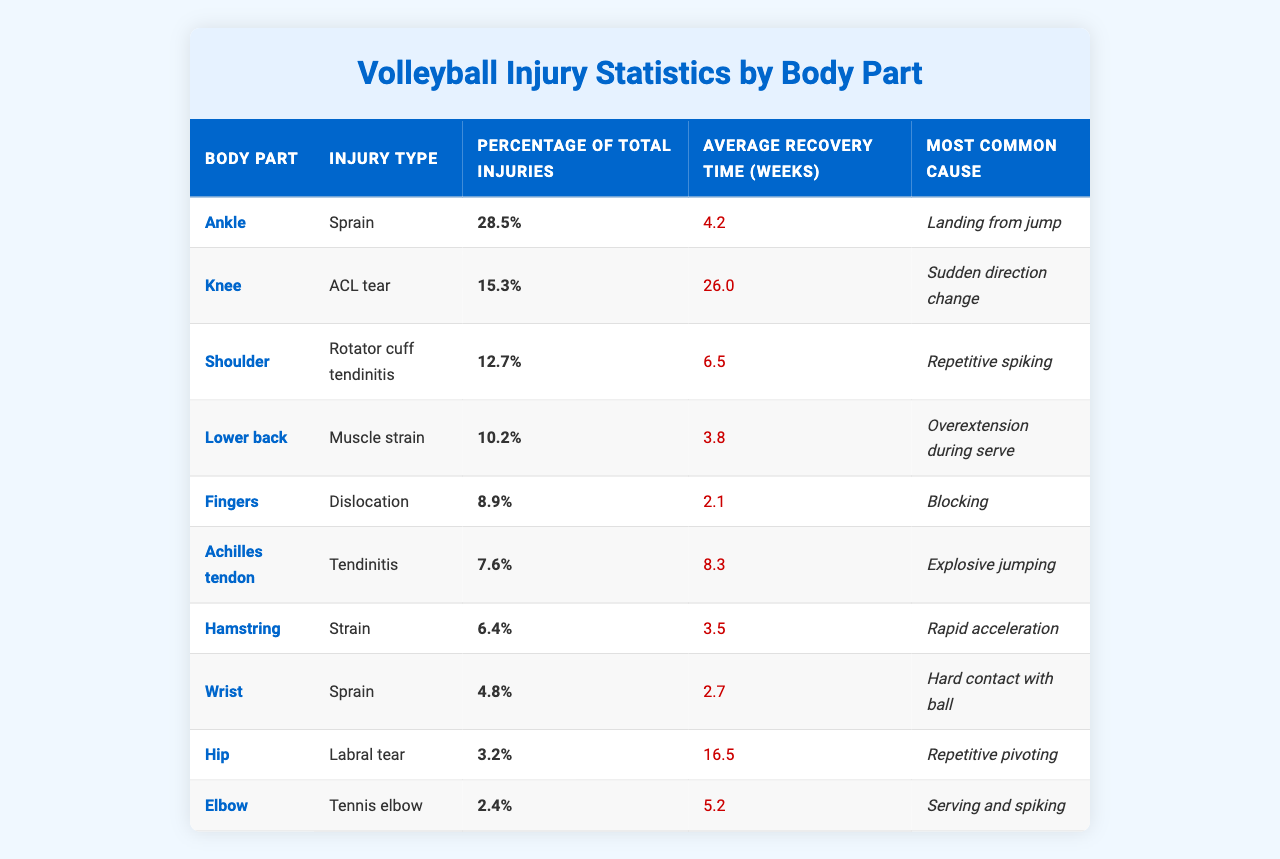What body part has the highest percentage of total injuries? By examining the "Percentage of Total Injuries" column, we can see that the Ankle has the highest percentage at 28.5%.
Answer: Ankle What is the average recovery time for an ACL tear? Looking at the "Average Recovery Time (weeks)" column for the Knee injury type, the average recovery time for an ACL tear is 26.0 weeks.
Answer: 26.0 weeks Which body part is most commonly injured due to landing from a jump? The "Most Common Cause" for Ankle injuries is "Landing from jump," indicating the Ankle is the body part most affected by this activity.
Answer: Ankle How many body parts have an average recovery time of 3.5 weeks or less? Checking the "Average Recovery Time (weeks)" column, only the Lower back (3.8 weeks), Fingers (2.1 weeks), and Wrist (2.7 weeks) fit this criterion, so there are 3 body parts.
Answer: 3 Is it true that the Achilles tendon injuries are more common than Finger dislocations? By comparing the "Percentage of Total Injuries," Achilles tendon injuries at 7.6% are less common than Finger dislocations at 8.9%. Thus, the statement is false.
Answer: False What percentage of total injuries is accounted for by shoulder and knee injuries combined? The percentage for Shoulder injuries (12.7%) and Knee injuries (15.3%) adds up to 28.0%. Therefore, the combined percentage is 28.0%.
Answer: 28.0% Which injury type has the longest average recovery time and what is it? The "Average Recovery Time (weeks)" for an ACL tear is indicated as 26.0 weeks, which is the longest compared to all other injuries listed in the table.
Answer: ACL tear, 26.0 weeks What is the average recovery time for injuries caused by explosive jumping? The only injury type associated with explosive jumping is Achilles tendon (Tendinitis), which has an average recovery time of 8.3 weeks.
Answer: 8.3 weeks Are injuries from repetitive pivoting more common than wrist sprains? Comparing "Percentage of Total Injuries," Labral tears (3.2%) from pivoting are less common than Wrist sprains (4.8%), making the statement false.
Answer: False What is the difference in percentage of total injuries between the Ankle sprain and the Hamstring strain? The percentage for Ankle injuries (28.5%) minus Hamstring injuries (6.4%) results in a difference of 22.1%.
Answer: 22.1% 